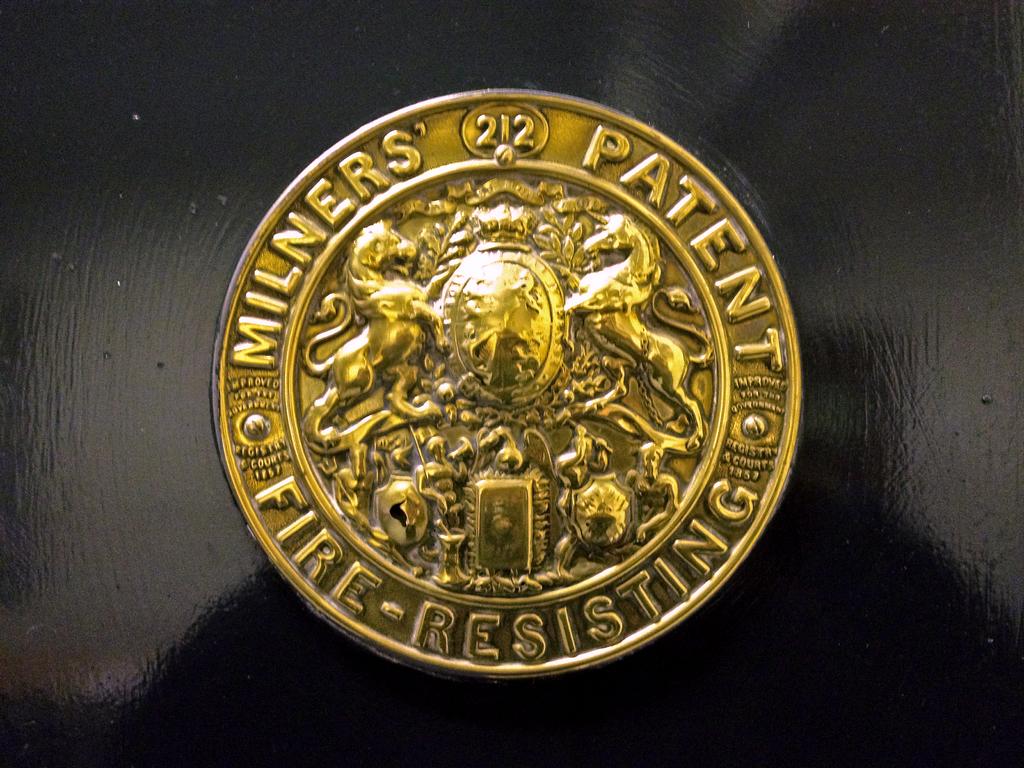What is resisting?
Offer a very short reply. Fire. What type of patent?
Offer a terse response. Milners'. 